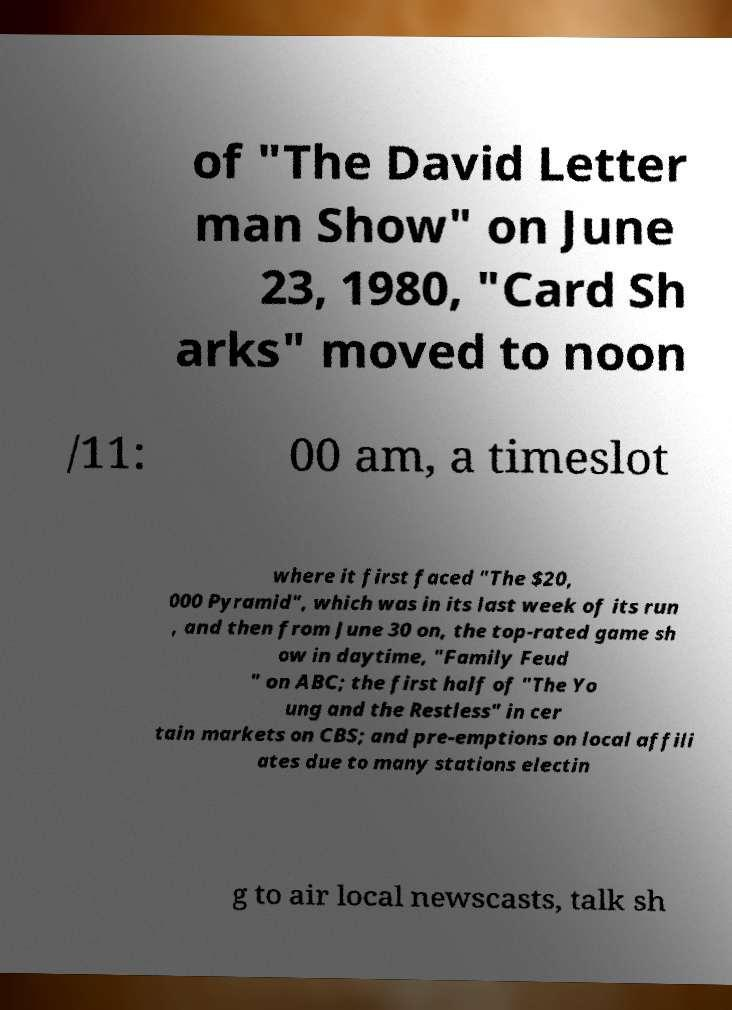Please read and relay the text visible in this image. What does it say? of "The David Letter man Show" on June 23, 1980, "Card Sh arks" moved to noon /11: 00 am, a timeslot where it first faced "The $20, 000 Pyramid", which was in its last week of its run , and then from June 30 on, the top-rated game sh ow in daytime, "Family Feud " on ABC; the first half of "The Yo ung and the Restless" in cer tain markets on CBS; and pre-emptions on local affili ates due to many stations electin g to air local newscasts, talk sh 